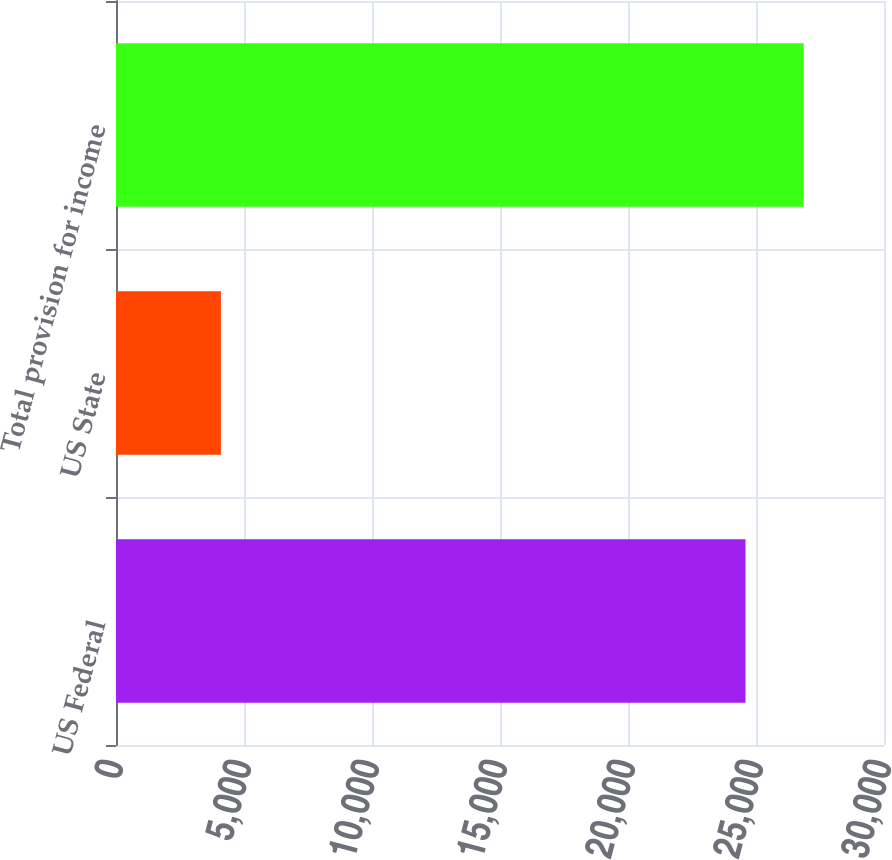<chart> <loc_0><loc_0><loc_500><loc_500><bar_chart><fcel>US Federal<fcel>US State<fcel>Total provision for income<nl><fcel>24590<fcel>4099<fcel>26863.3<nl></chart> 